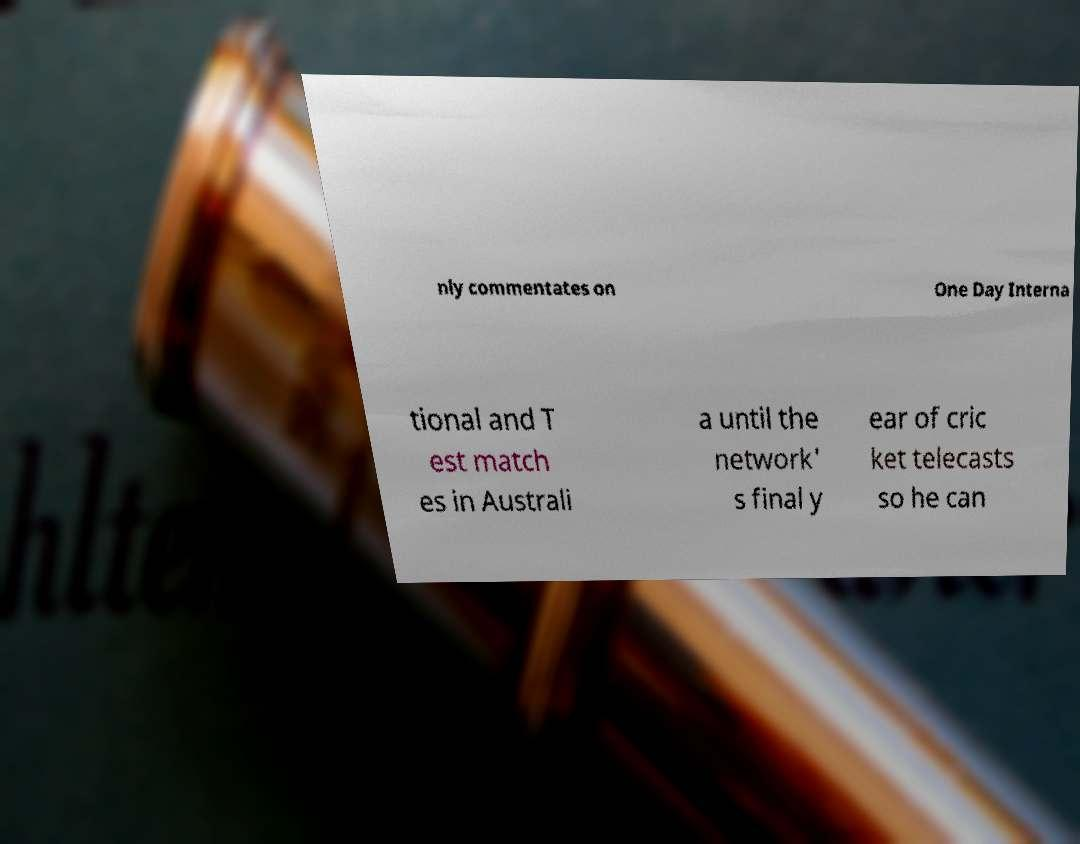Can you read and provide the text displayed in the image?This photo seems to have some interesting text. Can you extract and type it out for me? nly commentates on One Day Interna tional and T est match es in Australi a until the network' s final y ear of cric ket telecasts so he can 